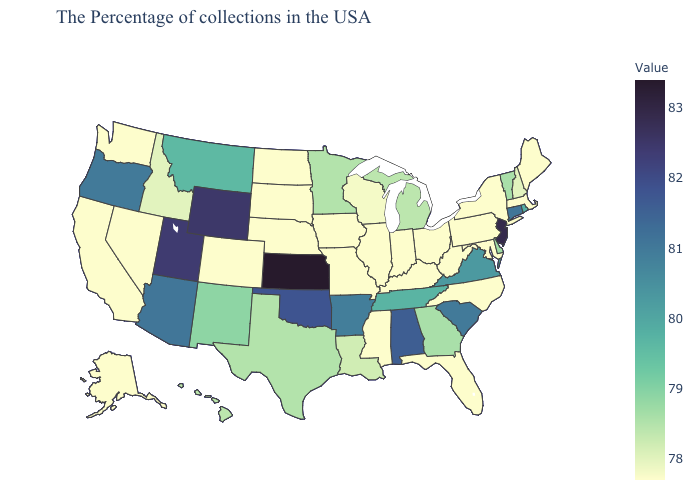Does Idaho have the lowest value in the West?
Quick response, please. No. Which states have the highest value in the USA?
Short answer required. Kansas. Does Pennsylvania have the lowest value in the USA?
Concise answer only. Yes. Does Kansas have the highest value in the USA?
Give a very brief answer. Yes. Which states have the lowest value in the MidWest?
Keep it brief. Ohio, Indiana, Illinois, Missouri, Iowa, Nebraska, South Dakota, North Dakota. Which states hav the highest value in the West?
Give a very brief answer. Wyoming. Which states have the highest value in the USA?
Write a very short answer. Kansas. Among the states that border Minnesota , which have the lowest value?
Quick response, please. Iowa, South Dakota, North Dakota. 